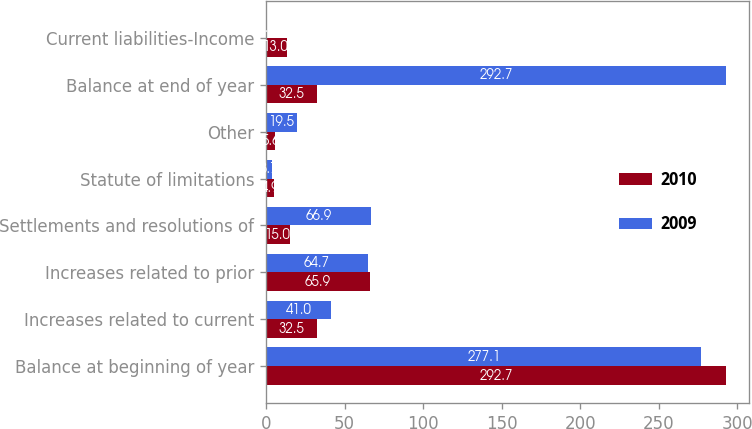<chart> <loc_0><loc_0><loc_500><loc_500><stacked_bar_chart><ecel><fcel>Balance at beginning of year<fcel>Increases related to current<fcel>Increases related to prior<fcel>Settlements and resolutions of<fcel>Statute of limitations<fcel>Other<fcel>Balance at end of year<fcel>Current liabilities-Income<nl><fcel>2010<fcel>292.7<fcel>32.5<fcel>65.9<fcel>15<fcel>4.9<fcel>5.6<fcel>32.5<fcel>13<nl><fcel>2009<fcel>277.1<fcel>41<fcel>64.7<fcel>66.9<fcel>3.7<fcel>19.5<fcel>292.7<fcel>0.5<nl></chart> 